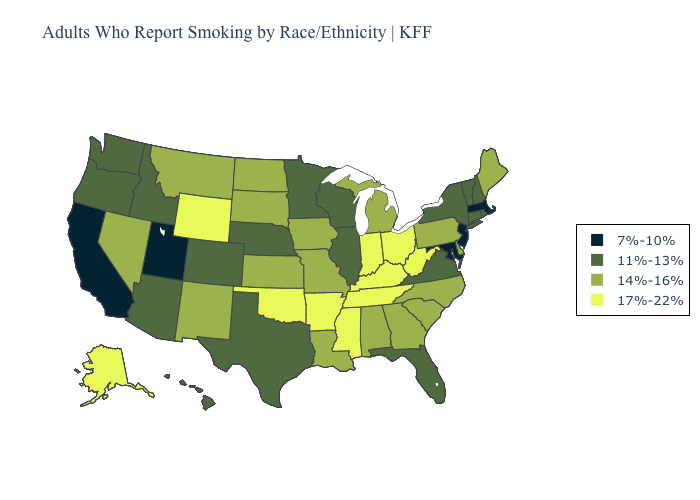What is the value of Kansas?
Answer briefly. 14%-16%. Name the states that have a value in the range 11%-13%?
Keep it brief. Arizona, Colorado, Connecticut, Florida, Hawaii, Idaho, Illinois, Minnesota, Nebraska, New Hampshire, New York, Oregon, Rhode Island, Texas, Vermont, Virginia, Washington, Wisconsin. Does Kentucky have a higher value than West Virginia?
Write a very short answer. No. What is the highest value in the Northeast ?
Write a very short answer. 14%-16%. What is the lowest value in states that border Nevada?
Be succinct. 7%-10%. What is the highest value in states that border New York?
Give a very brief answer. 14%-16%. What is the value of Virginia?
Short answer required. 11%-13%. Name the states that have a value in the range 14%-16%?
Concise answer only. Alabama, Delaware, Georgia, Iowa, Kansas, Louisiana, Maine, Michigan, Missouri, Montana, Nevada, New Mexico, North Carolina, North Dakota, Pennsylvania, South Carolina, South Dakota. Which states have the lowest value in the MidWest?
Write a very short answer. Illinois, Minnesota, Nebraska, Wisconsin. Does Rhode Island have a higher value than Massachusetts?
Write a very short answer. Yes. Does Oklahoma have a higher value than Kentucky?
Answer briefly. No. Name the states that have a value in the range 7%-10%?
Short answer required. California, Maryland, Massachusetts, New Jersey, Utah. Which states have the lowest value in the USA?
Concise answer only. California, Maryland, Massachusetts, New Jersey, Utah. Does Utah have the lowest value in the USA?
Be succinct. Yes. 